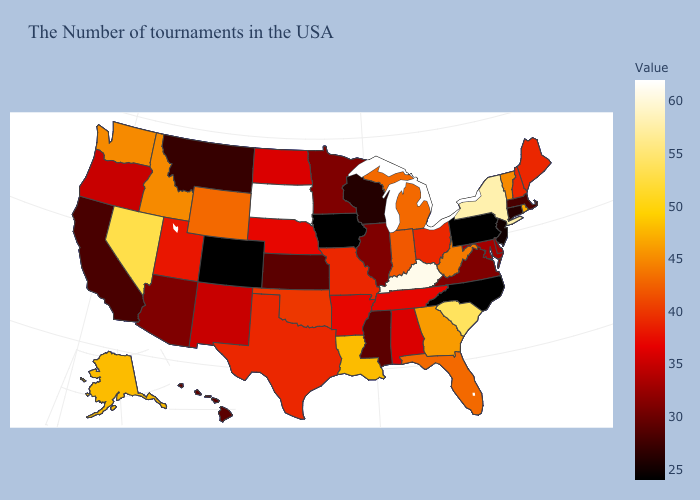Which states have the lowest value in the USA?
Write a very short answer. Pennsylvania, North Carolina, Iowa, Colorado. Among the states that border Ohio , does West Virginia have the lowest value?
Concise answer only. No. Does North Carolina have the lowest value in the South?
Keep it brief. Yes. Which states have the lowest value in the Northeast?
Answer briefly. Pennsylvania. Does New York have a higher value than South Dakota?
Concise answer only. No. Among the states that border Oregon , which have the lowest value?
Be succinct. California. Does the map have missing data?
Answer briefly. No. 